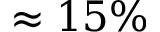Convert formula to latex. <formula><loc_0><loc_0><loc_500><loc_500>\approx 1 5 \%</formula> 